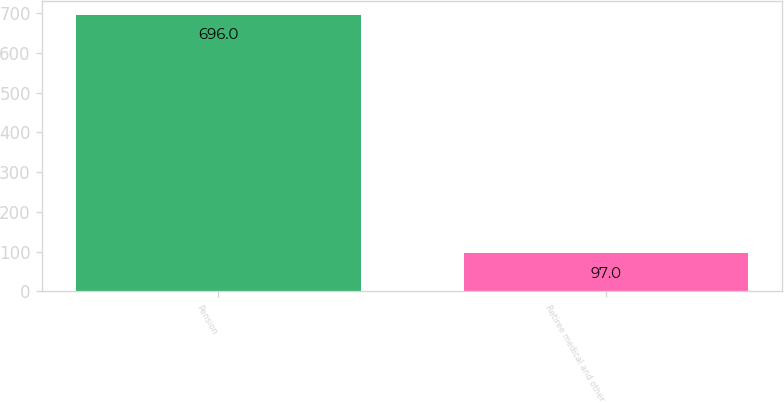Convert chart. <chart><loc_0><loc_0><loc_500><loc_500><bar_chart><fcel>Pension<fcel>Retiree medical and other<nl><fcel>696<fcel>97<nl></chart> 